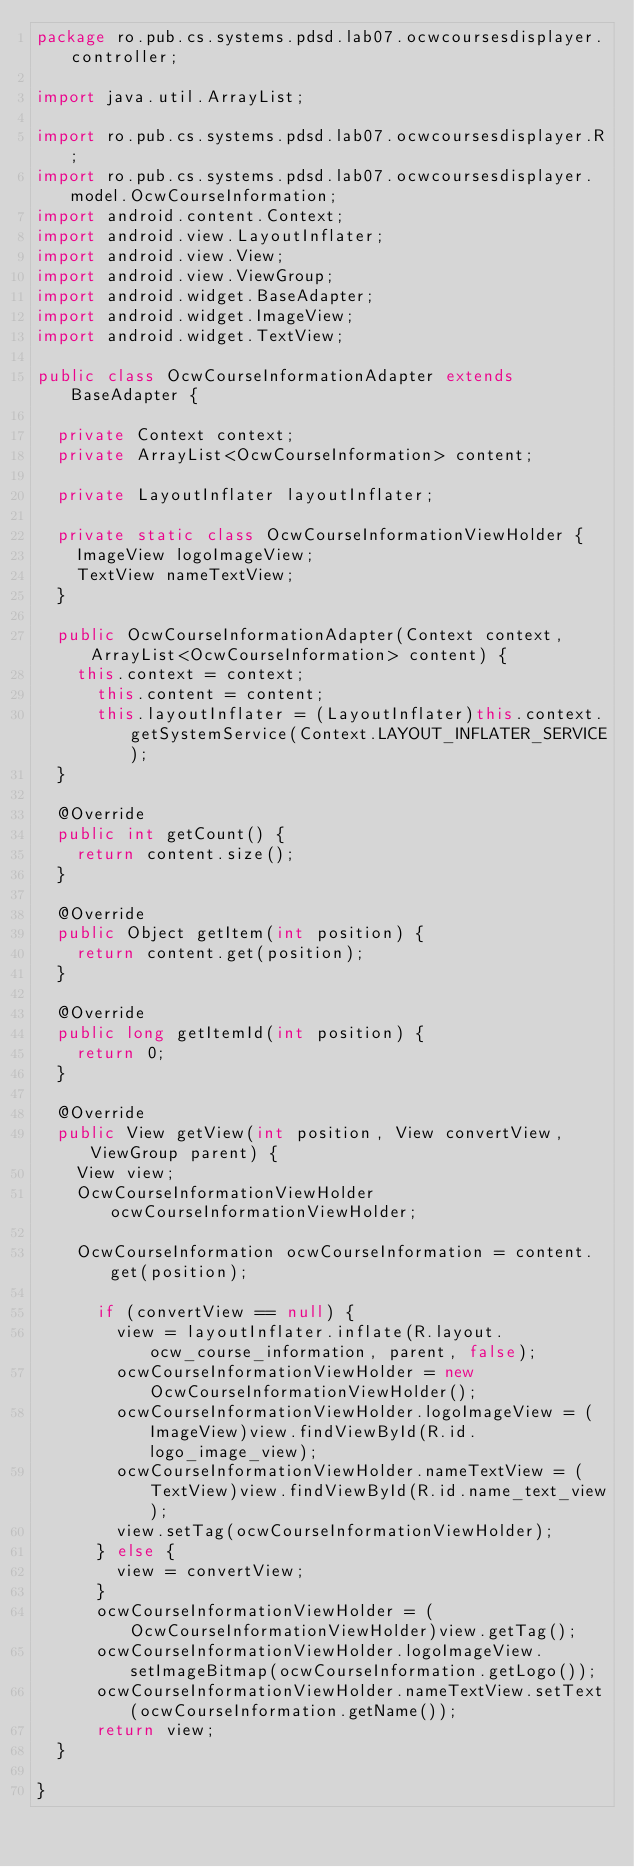Convert code to text. <code><loc_0><loc_0><loc_500><loc_500><_Java_>package ro.pub.cs.systems.pdsd.lab07.ocwcoursesdisplayer.controller;

import java.util.ArrayList;

import ro.pub.cs.systems.pdsd.lab07.ocwcoursesdisplayer.R;
import ro.pub.cs.systems.pdsd.lab07.ocwcoursesdisplayer.model.OcwCourseInformation;
import android.content.Context;
import android.view.LayoutInflater;
import android.view.View;
import android.view.ViewGroup;
import android.widget.BaseAdapter;
import android.widget.ImageView;
import android.widget.TextView;

public class OcwCourseInformationAdapter extends BaseAdapter {

	private Context context;
	private ArrayList<OcwCourseInformation> content;
	
	private LayoutInflater layoutInflater;
	
	private static class OcwCourseInformationViewHolder {
		ImageView logoImageView;
		TextView nameTextView;
	}
	
	public OcwCourseInformationAdapter(Context context, ArrayList<OcwCourseInformation> content) {
		this.context = context;
	    this.content = content;
	    this.layoutInflater = (LayoutInflater)this.context.getSystemService(Context.LAYOUT_INFLATER_SERVICE);
	}

	@Override
	public int getCount() {
		return content.size();
	}

	@Override
	public Object getItem(int position) {
		return content.get(position);
	}
	
	@Override
	public long getItemId(int position) {
		return 0;
	}
	
	@Override
	public View getView(int position, View convertView, ViewGroup parent) {
		View view;
		OcwCourseInformationViewHolder ocwCourseInformationViewHolder;
		
		OcwCourseInformation ocwCourseInformation = content.get(position);
		
	    if (convertView == null) {  
	      view = layoutInflater.inflate(R.layout.ocw_course_information, parent, false);
	      ocwCourseInformationViewHolder = new OcwCourseInformationViewHolder();
	      ocwCourseInformationViewHolder.logoImageView = (ImageView)view.findViewById(R.id.logo_image_view);
	      ocwCourseInformationViewHolder.nameTextView = (TextView)view.findViewById(R.id.name_text_view);
	      view.setTag(ocwCourseInformationViewHolder);
	    } else {
	      view = convertView;
	    }
	    ocwCourseInformationViewHolder = (OcwCourseInformationViewHolder)view.getTag();
	    ocwCourseInformationViewHolder.logoImageView.setImageBitmap(ocwCourseInformation.getLogo());
	    ocwCourseInformationViewHolder.nameTextView.setText(ocwCourseInformation.getName());
	    return view;
	}

}
</code> 